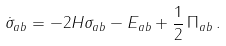Convert formula to latex. <formula><loc_0><loc_0><loc_500><loc_500>\dot { \sigma } _ { a b } = - 2 H \sigma _ { a b } - E _ { a b } + { \frac { 1 } { 2 } } \, \Pi _ { a b } \, .</formula> 